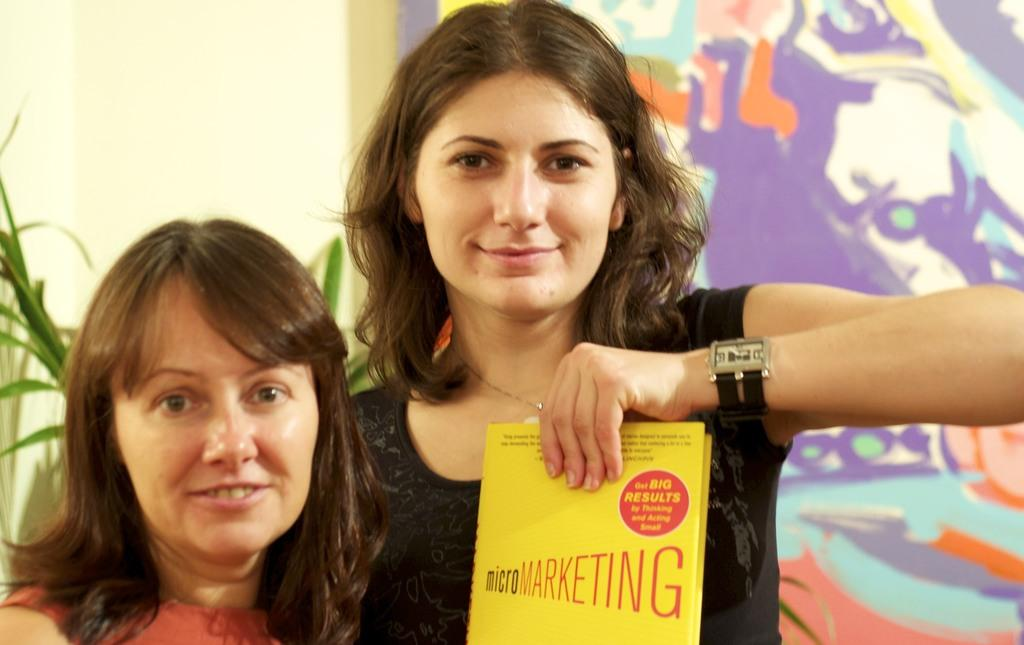<image>
Provide a brief description of the given image. Two women, one of whom is holding up a book on micro marketing. 